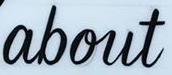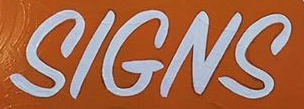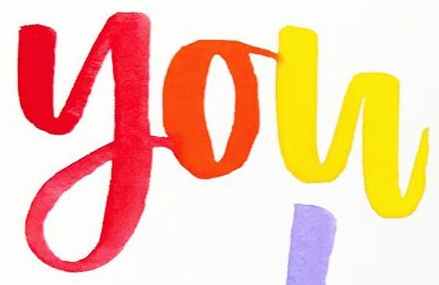What text is displayed in these images sequentially, separated by a semicolon? about; SIGNS; you 